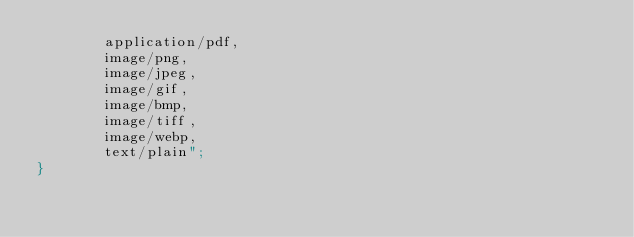<code> <loc_0><loc_0><loc_500><loc_500><_C#_>        application/pdf,
        image/png,
        image/jpeg,
        image/gif,
        image/bmp,
        image/tiff,
        image/webp,
        text/plain";
}
</code> 